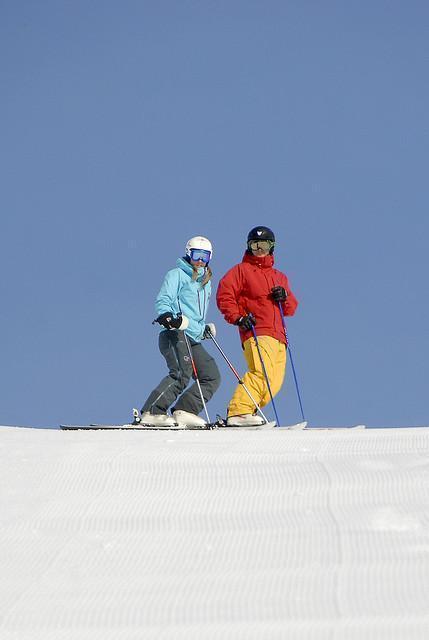How many people are there?
Give a very brief answer. 2. 